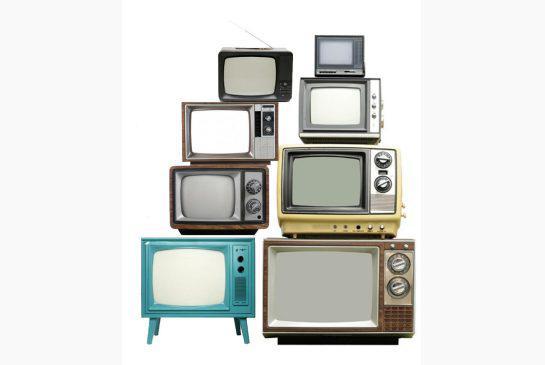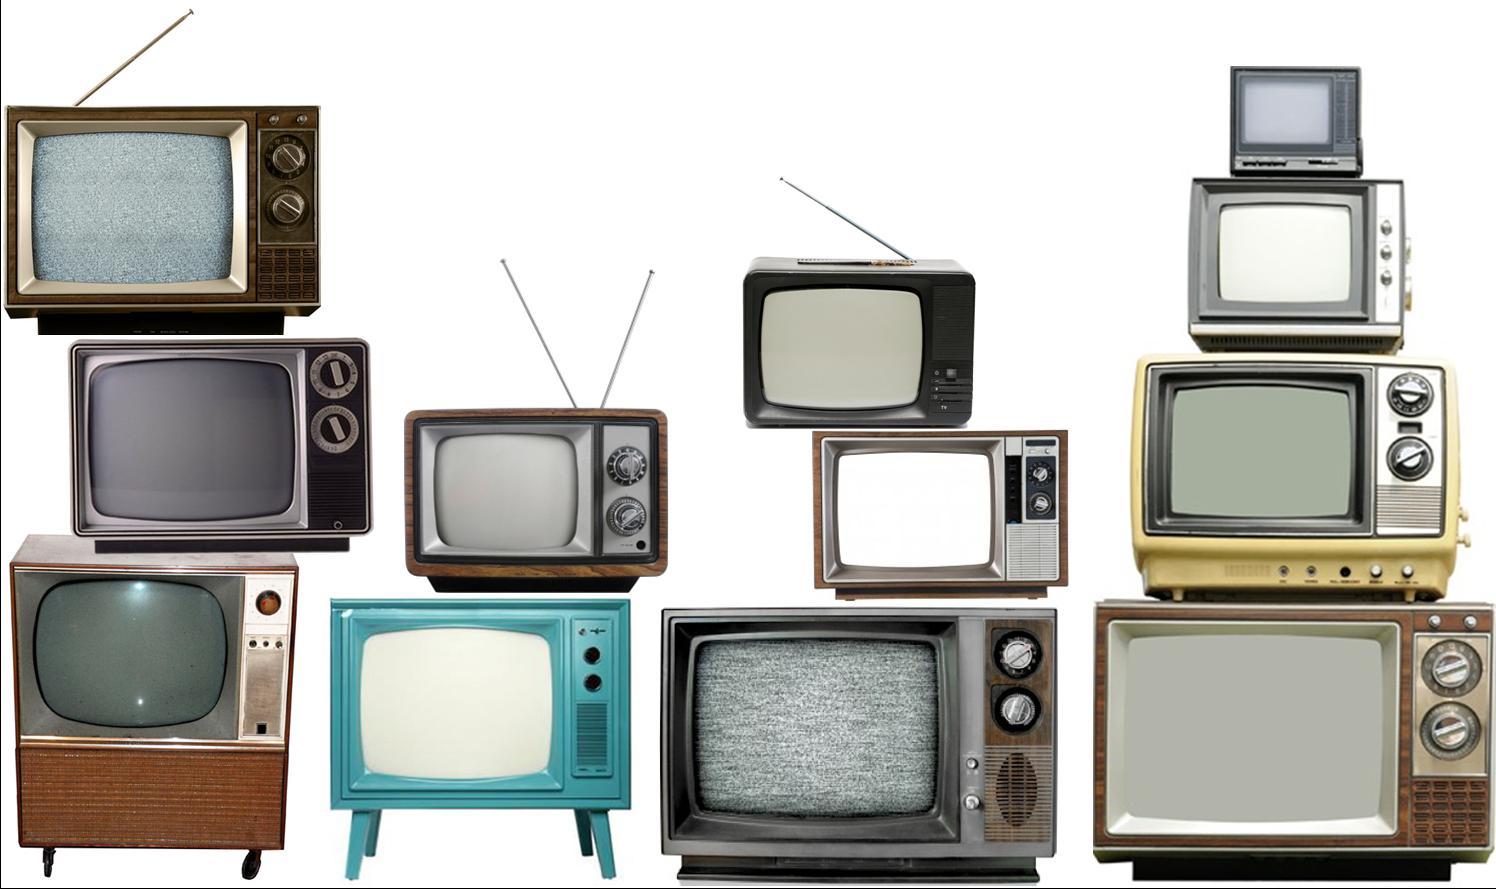The first image is the image on the left, the second image is the image on the right. Considering the images on both sides, is "Tv's are stacked on a wood floor with a white wall" valid? Answer yes or no. No. The first image is the image on the left, the second image is the image on the right. Examine the images to the left and right. Is the description "In one image, the monitors are stacked in the shape of an animal or person." accurate? Answer yes or no. No. 